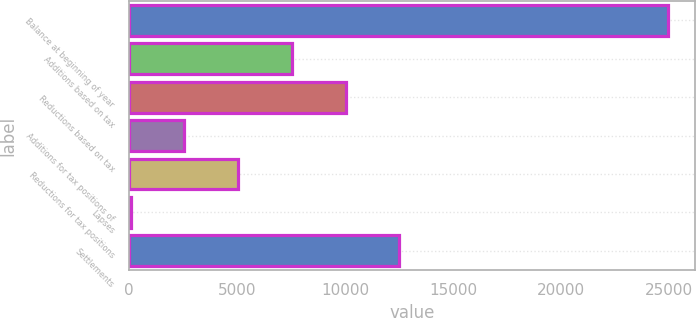<chart> <loc_0><loc_0><loc_500><loc_500><bar_chart><fcel>Balance at beginning of year<fcel>Additions based on tax<fcel>Reductions based on tax<fcel>Additions for tax positions of<fcel>Reductions for tax positions<fcel>Lapses<fcel>Settlements<nl><fcel>24955<fcel>7537.6<fcel>10025.8<fcel>2561.2<fcel>5049.4<fcel>73<fcel>12514<nl></chart> 